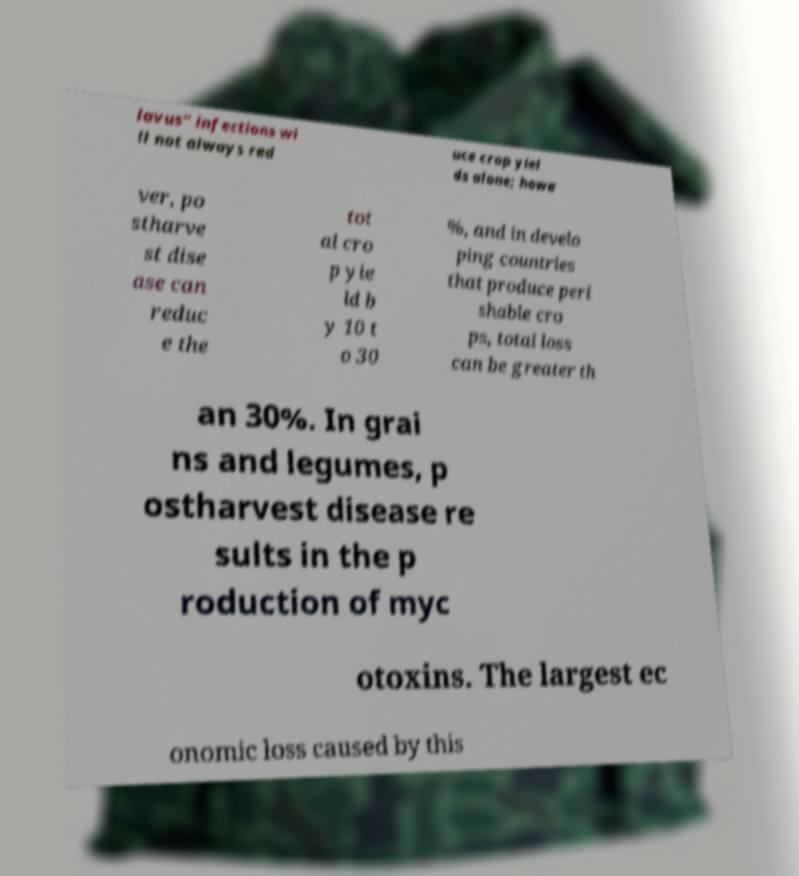Please read and relay the text visible in this image. What does it say? lavus" infections wi ll not always red uce crop yiel ds alone; howe ver, po stharve st dise ase can reduc e the tot al cro p yie ld b y 10 t o 30 %, and in develo ping countries that produce peri shable cro ps, total loss can be greater th an 30%. In grai ns and legumes, p ostharvest disease re sults in the p roduction of myc otoxins. The largest ec onomic loss caused by this 